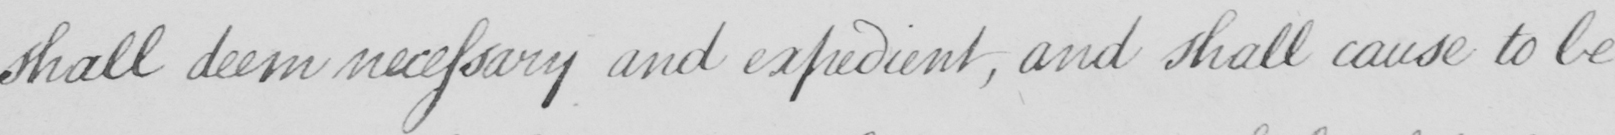What text is written in this handwritten line? shall deem necessary and expedient , and shall cause to be 